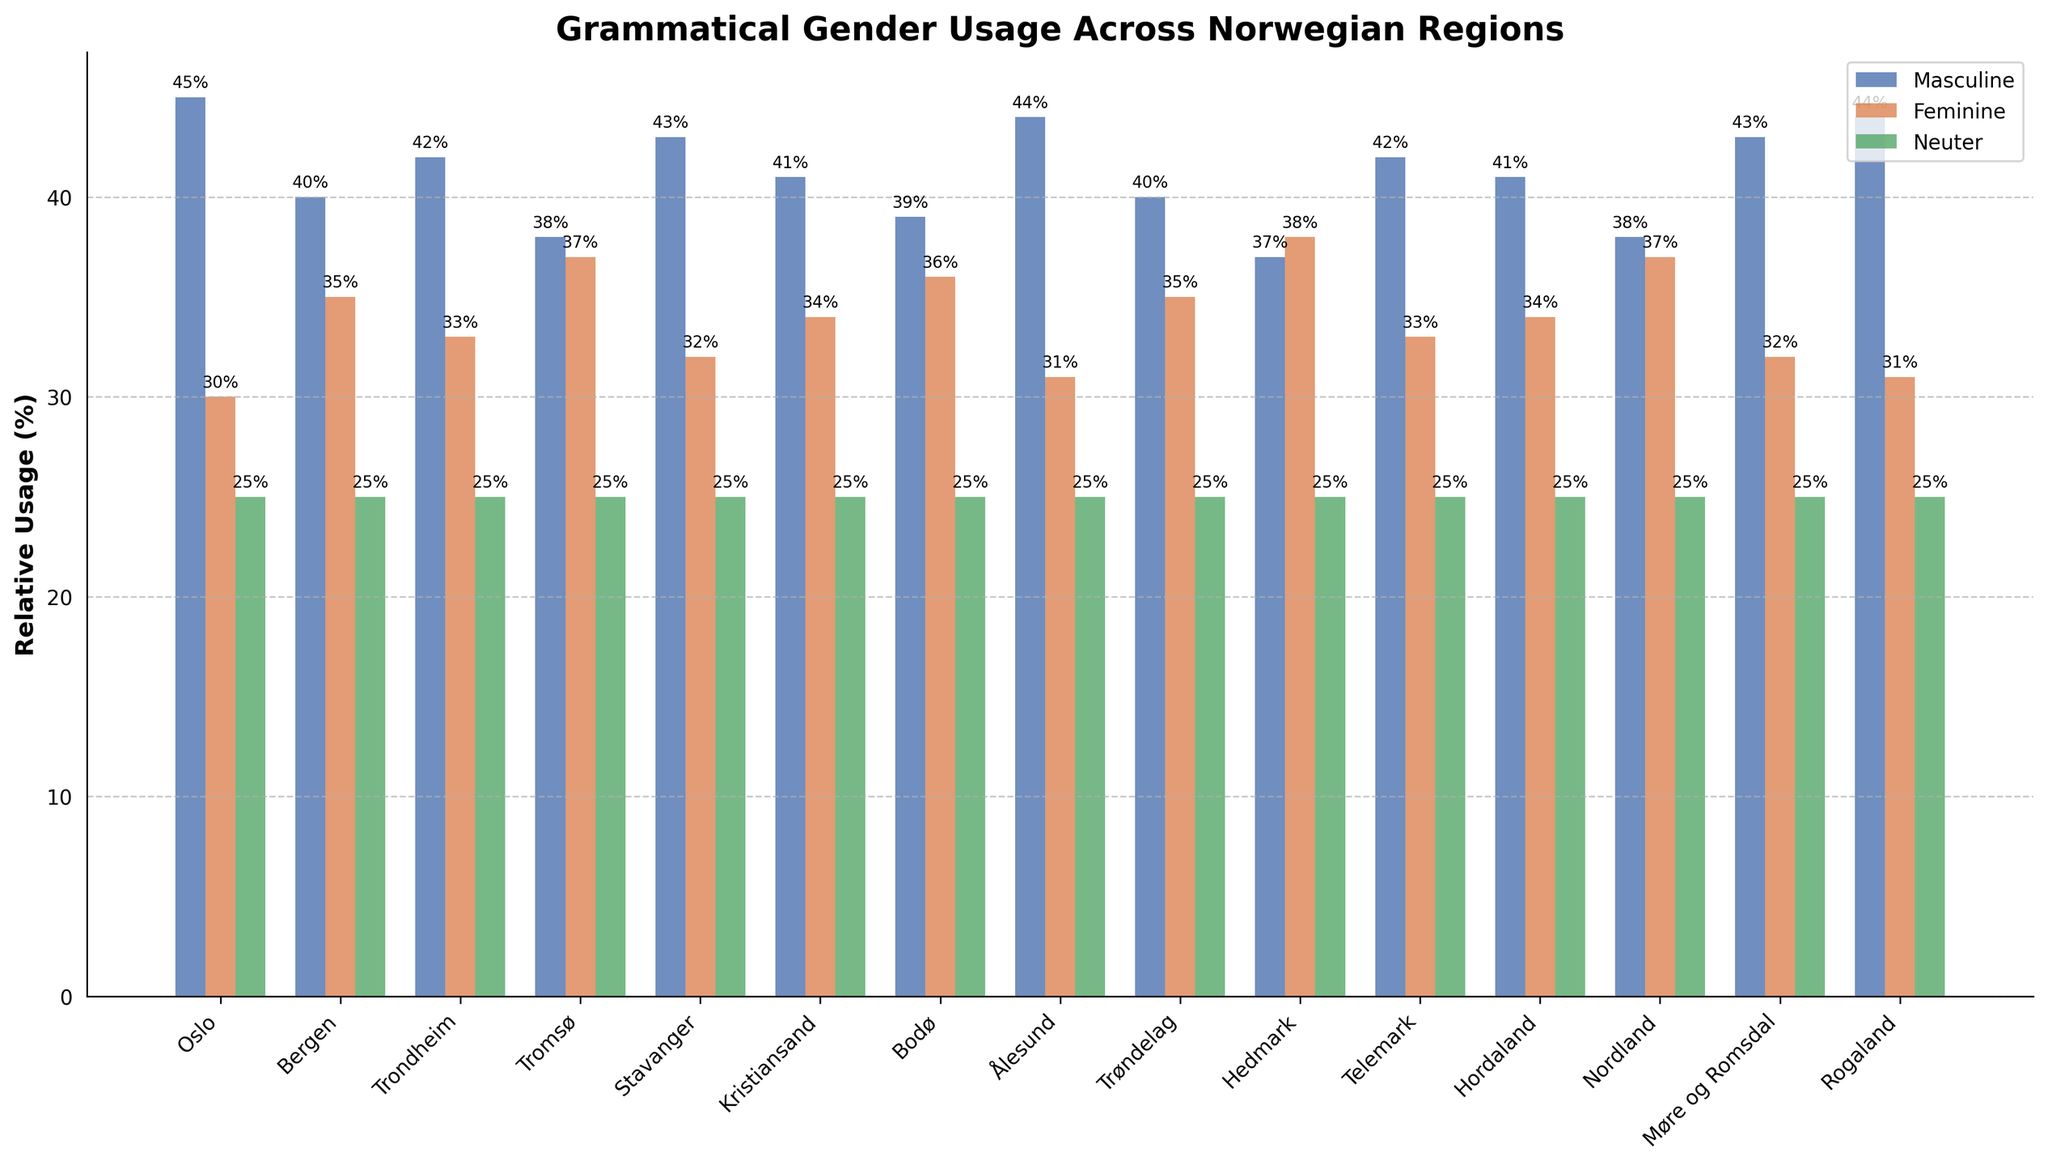Which region has the highest relative usage of masculine grammatical gender? By looking at the heights of the blue bars labeled "Masculine," we identify that Oslo and Rogaland have the tallest bars.
Answer: Oslo and Rogaland What is the difference in relative usage of feminine grammatical gender between Oslo and Bergen? From the red bars labeled "Feminine," we see that Oslo has a height of 30% and Bergen has a height of 35%. The difference is 35% - 30% = 5%.
Answer: 5% Which region shows the least relative usage of the masculine grammatical gender? By comparing the heights of the blue bars across all regions, we see that Hedmark has the shortest bar at 37%.
Answer: Hedmark How does the usage of neuter grammatical gender compare across all regions? All green bars labeled "Neuter" are at the same level, indicating uniform usage across all regions.
Answer: Uniform at 25% What's the average relative usage of feminine grammatical gender in Oslo, Bergen, and Trondheim? First, we note the values: Oslo (30%), Bergen (35%), Trondheim (33%). We sum them: 30% + 35% + 33% = 98%, then divide by 3 to get the average: 98% / 3 ≈ 32.67%.
Answer: 32.67% Which region has the closest relative usage percentages for masculine and feminine grammatical genders? By evaluating pairs of blue and red bars for each region, Hedmark comes closest with 37% for masculine and 38% for feminine. The difference is only 1%.
Answer: Hedmark Identify the region where the difference between masculine and neopausal grammatical gender is the greatest. Calculate the differences between blue and green bars for each region and identify the largest. Bergen, Trondheim, and all regions show a difference of 15% (40%-25% or 42%-25%).
Answer: Multiple regions (Oslo, Stavanger, Ålesund, Rogaland) In which region does feminine grammatical gender surpass masculine grammatical gender the most? The largest difference occurs where the difference between the red and blue bars is the largest. Tromsø and Bodø both have differences of 37% - 38% and Hedmark shows a larger 37% – 38%.
Answer: Hedmark What is the combined relative usage of masculine and feminine grammatical gender in Tromsø? The values for Tromsø are 38% for masculine and 37% for feminine. Combined, 38% + 37% = 75%.
Answer: 75% Is there any region where the usage of feminine grammatical gender is equal to that of either masculine or neuter grammatical gender? By examining heights of red bars and comparing with blue and green, there's no region with feminine usage equal to masculine or neuter.
Answer: No 